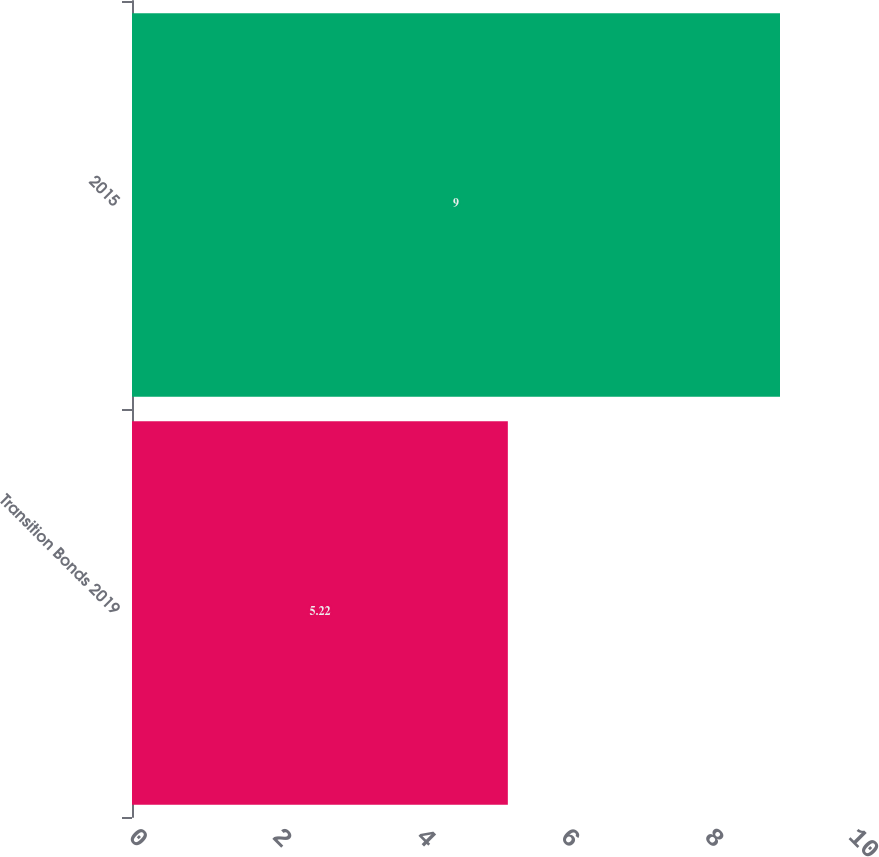Convert chart to OTSL. <chart><loc_0><loc_0><loc_500><loc_500><bar_chart><fcel>Transition Bonds 2019<fcel>2015<nl><fcel>5.22<fcel>9<nl></chart> 